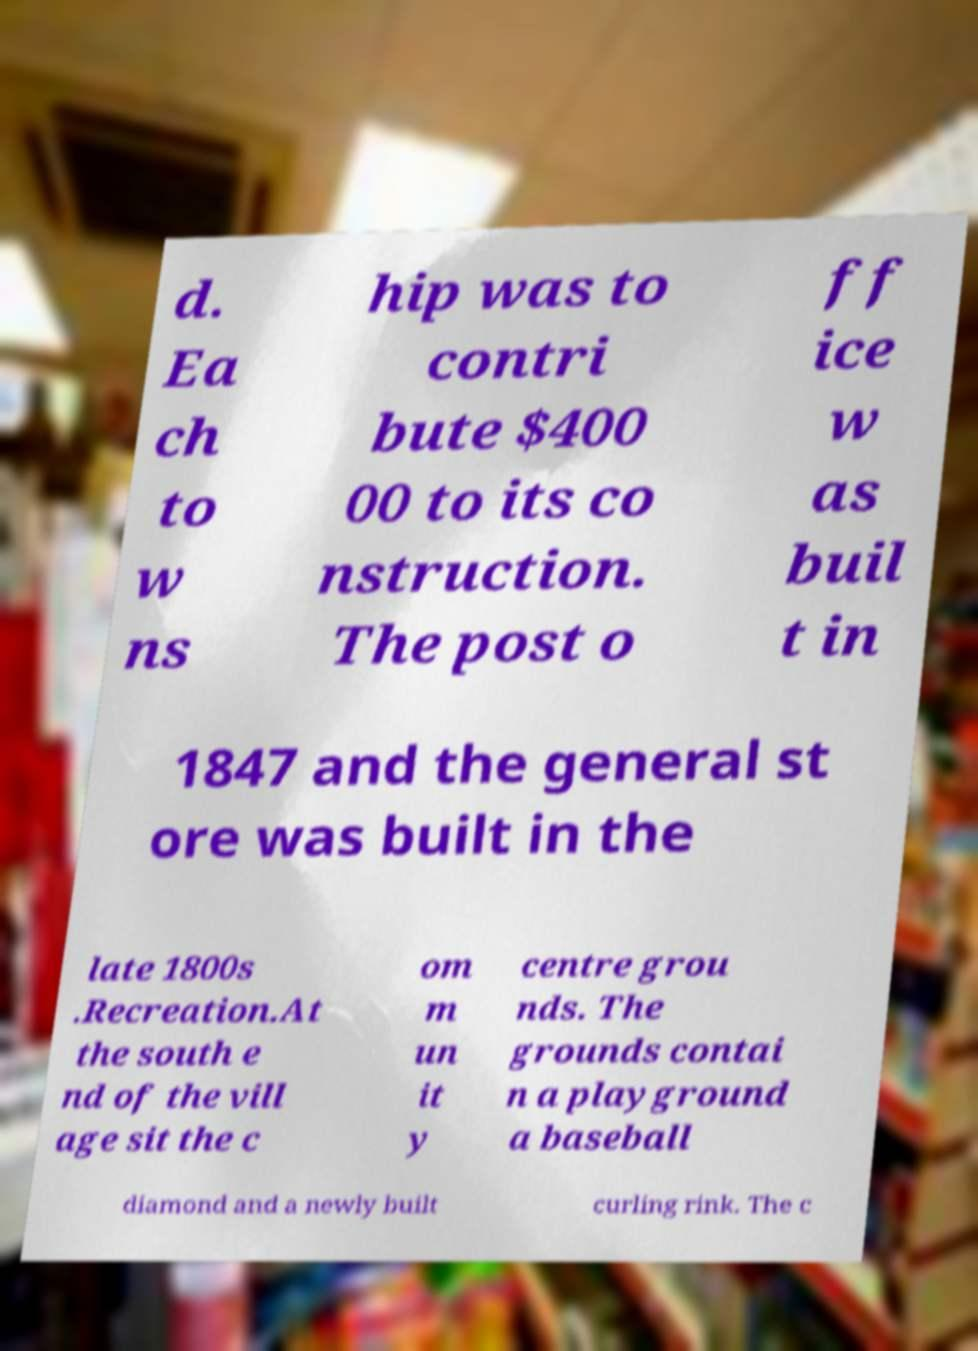What messages or text are displayed in this image? I need them in a readable, typed format. d. Ea ch to w ns hip was to contri bute $400 00 to its co nstruction. The post o ff ice w as buil t in 1847 and the general st ore was built in the late 1800s .Recreation.At the south e nd of the vill age sit the c om m un it y centre grou nds. The grounds contai n a playground a baseball diamond and a newly built curling rink. The c 